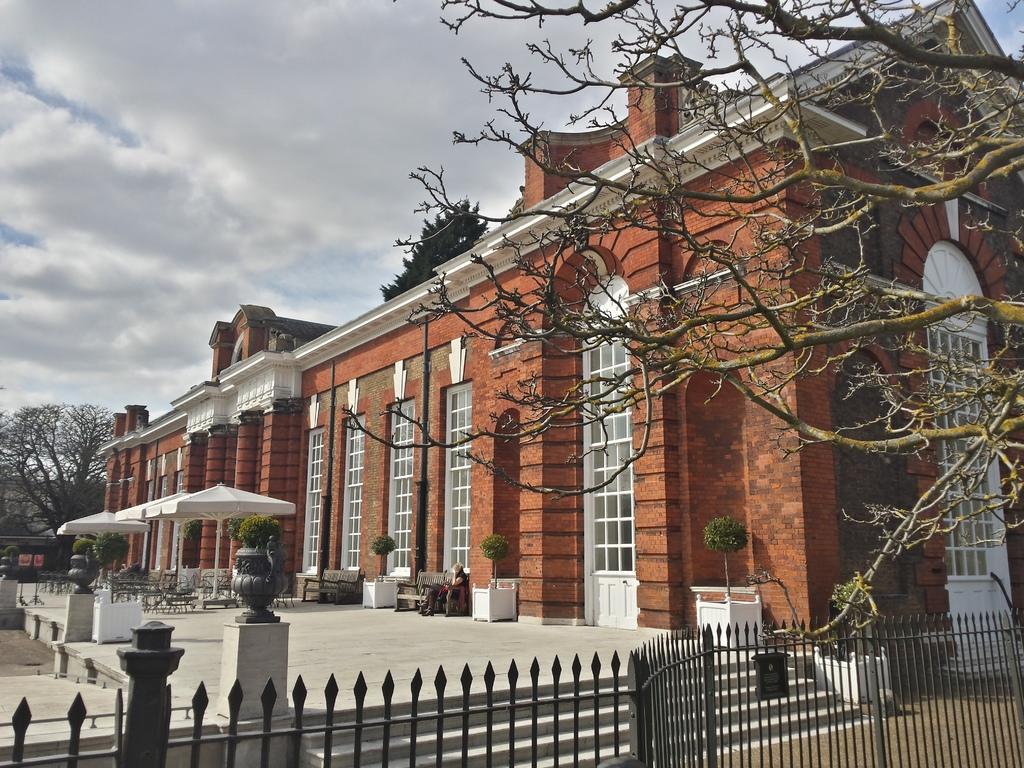How would you summarize this image in a sentence or two? In the picture we can see a building and around it we can see a railing and a tree which is dried and to the other side, we can see a tree and in the background we can see a sky with clouds. 